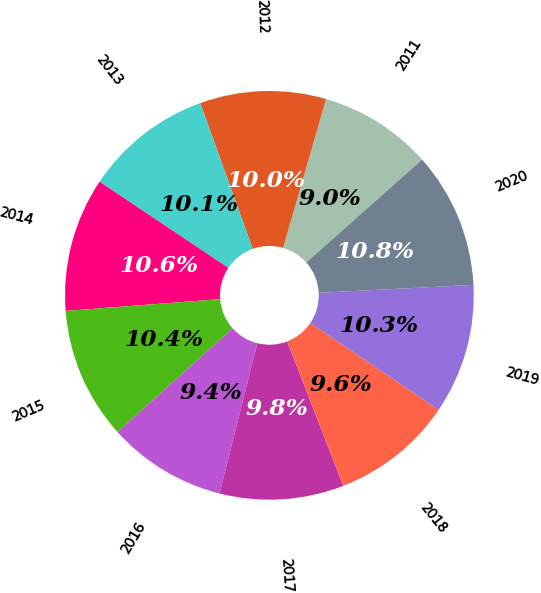<chart> <loc_0><loc_0><loc_500><loc_500><pie_chart><fcel>2011<fcel>2012<fcel>2013<fcel>2014<fcel>2015<fcel>2016<fcel>2017<fcel>2018<fcel>2019<fcel>2020<nl><fcel>8.96%<fcel>9.97%<fcel>10.12%<fcel>10.6%<fcel>10.44%<fcel>9.42%<fcel>9.81%<fcel>9.65%<fcel>10.28%<fcel>10.75%<nl></chart> 